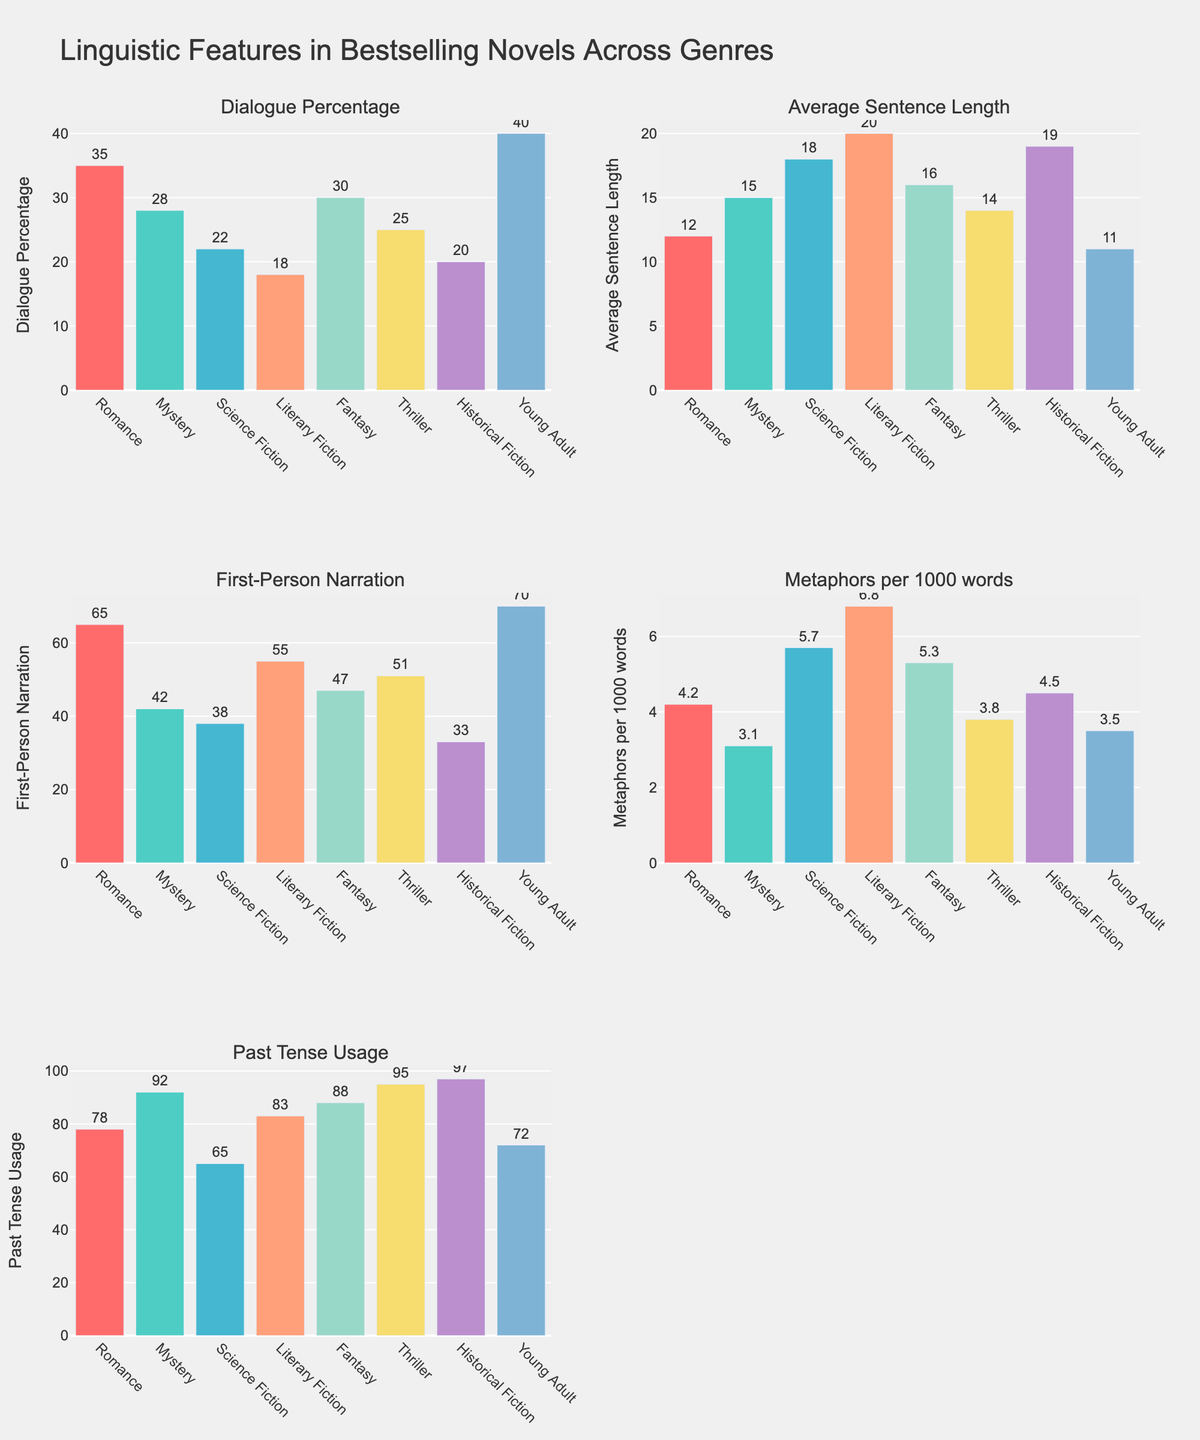What is the percentage of dialogue in Romance novels? To find the percentage of dialogue in Romance novels, refer to the "Dialogue Percentage" subplot. The Romance bar indicates 35%.
Answer: 35% Which genre has the highest average sentence length? To identify the genre with the highest average sentence length, look at the "Average Sentence Length" subplot. The tallest bar represents Literary Fiction with 20.
Answer: Literary Fiction Is the use of first-person narration more common in Romance or Fantasy genres? Compare the "First-Person Narration" subplot for Romance and Fantasy. Romance shows 65, while Fantasy shows 47. Therefore, first-person narration is more common in Romance.
Answer: Romance Which genre has the lowest use of metaphors per 1000 words? Locate the "Metaphors per 1000 words" subplot and find the shortest bar. Mystery has the lowest with 3.1.
Answer: Mystery What is the predominant tense used in Historical Fiction novels? In the subplot "Past Tense Usage," check the bar for Historical Fiction. It shows 97, indicating high usage of past tense.
Answer: Past tense How does the percentage of dialogue in Young Adult novels compare to Mystery novels? Look at the "Dialogue Percentage" subplot for both genres. Young Adult is at 40%, while Mystery is at 28%. Young Adult shows a higher percentage.
Answer: Young Adult What is the difference in average sentence length between Science Fiction and Young Adult genres? Refer to the "Average Sentence Length" subplot. Science Fiction has 18, Young Adult has 11. The difference is 18 - 11 = 7.
Answer: 7 Which genre has the highest usage of past tense, and what is the value? Check the "Past Tense Usage" subplot for the tallest bar. Thriller has the highest at 95.
Answer: Thriller, 95 Between Romance and Young Adult genres, which one has more metaphors per 1000 words? Refer to the "Metaphors per 1000 words" subplot. Romance has 4.2, whereas Young Adult has 3.5. Therefore, Romance uses more metaphors.
Answer: Romance What is the median percentage of first-person narration across all genres? List the percentages from the "First-Person Narration" subplot: 65, 42, 38, 55, 47, 51, 33, 70. Arranged in order: 33, 38, 42, 47, 51, 55, 65, 70. Median is the average of the 4th and 5th values: (47+51)/2 = 49.
Answer: 49 